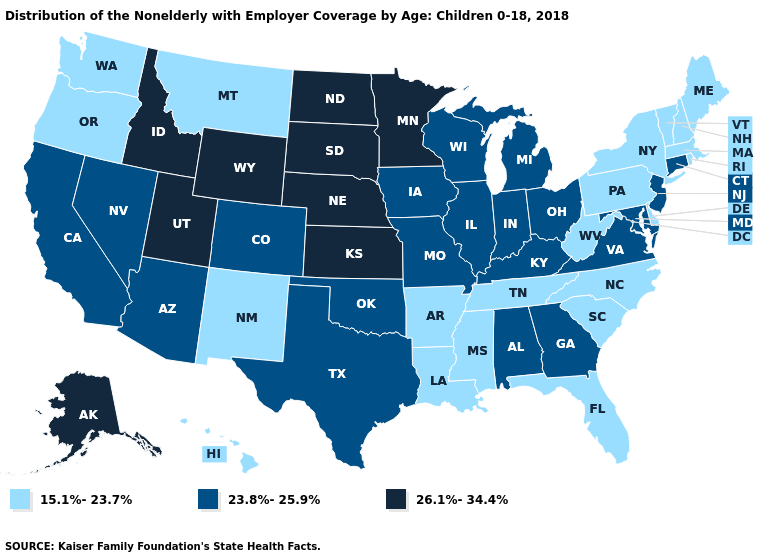Name the states that have a value in the range 15.1%-23.7%?
Concise answer only. Arkansas, Delaware, Florida, Hawaii, Louisiana, Maine, Massachusetts, Mississippi, Montana, New Hampshire, New Mexico, New York, North Carolina, Oregon, Pennsylvania, Rhode Island, South Carolina, Tennessee, Vermont, Washington, West Virginia. Among the states that border West Virginia , which have the lowest value?
Short answer required. Pennsylvania. Among the states that border North Carolina , does Tennessee have the lowest value?
Short answer required. Yes. Is the legend a continuous bar?
Give a very brief answer. No. What is the value of Kentucky?
Quick response, please. 23.8%-25.9%. What is the value of Florida?
Quick response, please. 15.1%-23.7%. Does Washington have the same value as Nebraska?
Short answer required. No. Among the states that border Wyoming , which have the highest value?
Write a very short answer. Idaho, Nebraska, South Dakota, Utah. Does Montana have the lowest value in the USA?
Give a very brief answer. Yes. Name the states that have a value in the range 15.1%-23.7%?
Concise answer only. Arkansas, Delaware, Florida, Hawaii, Louisiana, Maine, Massachusetts, Mississippi, Montana, New Hampshire, New Mexico, New York, North Carolina, Oregon, Pennsylvania, Rhode Island, South Carolina, Tennessee, Vermont, Washington, West Virginia. Does the map have missing data?
Write a very short answer. No. Which states have the lowest value in the USA?
Quick response, please. Arkansas, Delaware, Florida, Hawaii, Louisiana, Maine, Massachusetts, Mississippi, Montana, New Hampshire, New Mexico, New York, North Carolina, Oregon, Pennsylvania, Rhode Island, South Carolina, Tennessee, Vermont, Washington, West Virginia. What is the value of New Jersey?
Short answer required. 23.8%-25.9%. Is the legend a continuous bar?
Short answer required. No. 